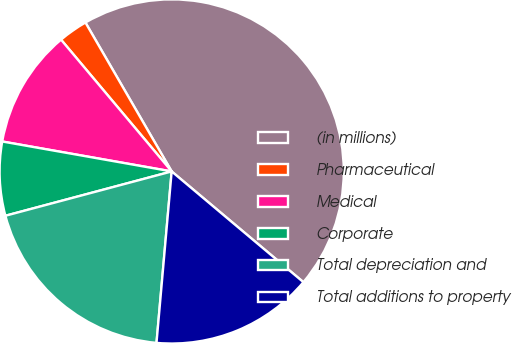Convert chart. <chart><loc_0><loc_0><loc_500><loc_500><pie_chart><fcel>(in millions)<fcel>Pharmaceutical<fcel>Medical<fcel>Corporate<fcel>Total depreciation and<fcel>Total additions to property<nl><fcel>44.48%<fcel>2.76%<fcel>11.1%<fcel>6.93%<fcel>19.45%<fcel>15.28%<nl></chart> 